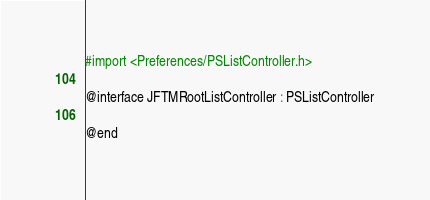Convert code to text. <code><loc_0><loc_0><loc_500><loc_500><_C_>#import <Preferences/PSListController.h>

@interface JFTMRootListController : PSListController

@end
</code> 